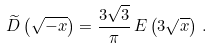Convert formula to latex. <formula><loc_0><loc_0><loc_500><loc_500>\widetilde { D } \left ( \sqrt { - x } \right ) = \frac { 3 \sqrt { 3 } } { \pi } \, E \left ( 3 \sqrt { x } \right ) \, .</formula> 